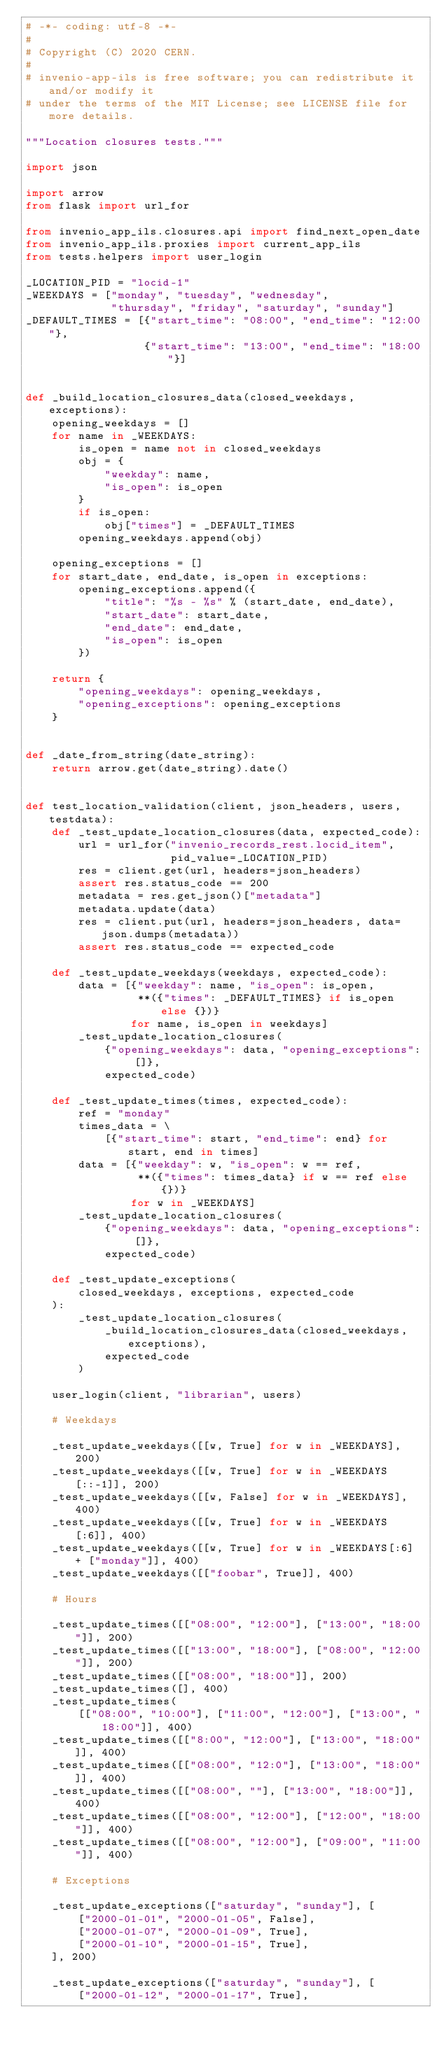Convert code to text. <code><loc_0><loc_0><loc_500><loc_500><_Python_># -*- coding: utf-8 -*-
#
# Copyright (C) 2020 CERN.
#
# invenio-app-ils is free software; you can redistribute it and/or modify it
# under the terms of the MIT License; see LICENSE file for more details.

"""Location closures tests."""

import json

import arrow
from flask import url_for

from invenio_app_ils.closures.api import find_next_open_date
from invenio_app_ils.proxies import current_app_ils
from tests.helpers import user_login

_LOCATION_PID = "locid-1"
_WEEKDAYS = ["monday", "tuesday", "wednesday",
             "thursday", "friday", "saturday", "sunday"]
_DEFAULT_TIMES = [{"start_time": "08:00", "end_time": "12:00"},
                  {"start_time": "13:00", "end_time": "18:00"}]


def _build_location_closures_data(closed_weekdays, exceptions):
    opening_weekdays = []
    for name in _WEEKDAYS:
        is_open = name not in closed_weekdays
        obj = {
            "weekday": name,
            "is_open": is_open
        }
        if is_open:
            obj["times"] = _DEFAULT_TIMES
        opening_weekdays.append(obj)

    opening_exceptions = []
    for start_date, end_date, is_open in exceptions:
        opening_exceptions.append({
            "title": "%s - %s" % (start_date, end_date),
            "start_date": start_date,
            "end_date": end_date,
            "is_open": is_open
        })

    return {
        "opening_weekdays": opening_weekdays,
        "opening_exceptions": opening_exceptions
    }


def _date_from_string(date_string):
    return arrow.get(date_string).date()


def test_location_validation(client, json_headers, users, testdata):
    def _test_update_location_closures(data, expected_code):
        url = url_for("invenio_records_rest.locid_item",
                      pid_value=_LOCATION_PID)
        res = client.get(url, headers=json_headers)
        assert res.status_code == 200
        metadata = res.get_json()["metadata"]
        metadata.update(data)
        res = client.put(url, headers=json_headers, data=json.dumps(metadata))
        assert res.status_code == expected_code

    def _test_update_weekdays(weekdays, expected_code):
        data = [{"weekday": name, "is_open": is_open,
                 **({"times": _DEFAULT_TIMES} if is_open else {})}
                for name, is_open in weekdays]
        _test_update_location_closures(
            {"opening_weekdays": data, "opening_exceptions": []},
            expected_code)

    def _test_update_times(times, expected_code):
        ref = "monday"
        times_data = \
            [{"start_time": start, "end_time": end} for start, end in times]
        data = [{"weekday": w, "is_open": w == ref,
                 **({"times": times_data} if w == ref else {})}
                for w in _WEEKDAYS]
        _test_update_location_closures(
            {"opening_weekdays": data, "opening_exceptions": []},
            expected_code)

    def _test_update_exceptions(
        closed_weekdays, exceptions, expected_code
    ):
        _test_update_location_closures(
            _build_location_closures_data(closed_weekdays, exceptions),
            expected_code
        )

    user_login(client, "librarian", users)

    # Weekdays

    _test_update_weekdays([[w, True] for w in _WEEKDAYS], 200)
    _test_update_weekdays([[w, True] for w in _WEEKDAYS[::-1]], 200)
    _test_update_weekdays([[w, False] for w in _WEEKDAYS], 400)
    _test_update_weekdays([[w, True] for w in _WEEKDAYS[:6]], 400)
    _test_update_weekdays([[w, True] for w in _WEEKDAYS[:6] + ["monday"]], 400)
    _test_update_weekdays([["foobar", True]], 400)

    # Hours

    _test_update_times([["08:00", "12:00"], ["13:00", "18:00"]], 200)
    _test_update_times([["13:00", "18:00"], ["08:00", "12:00"]], 200)
    _test_update_times([["08:00", "18:00"]], 200)
    _test_update_times([], 400)
    _test_update_times(
        [["08:00", "10:00"], ["11:00", "12:00"], ["13:00", "18:00"]], 400)
    _test_update_times([["8:00", "12:00"], ["13:00", "18:00"]], 400)
    _test_update_times([["08:00", "12:0"], ["13:00", "18:00"]], 400)
    _test_update_times([["08:00", ""], ["13:00", "18:00"]], 400)
    _test_update_times([["08:00", "12:00"], ["12:00", "18:00"]], 400)
    _test_update_times([["08:00", "12:00"], ["09:00", "11:00"]], 400)

    # Exceptions

    _test_update_exceptions(["saturday", "sunday"], [
        ["2000-01-01", "2000-01-05", False],
        ["2000-01-07", "2000-01-09", True],
        ["2000-01-10", "2000-01-15", True],
    ], 200)

    _test_update_exceptions(["saturday", "sunday"], [
        ["2000-01-12", "2000-01-17", True],</code> 